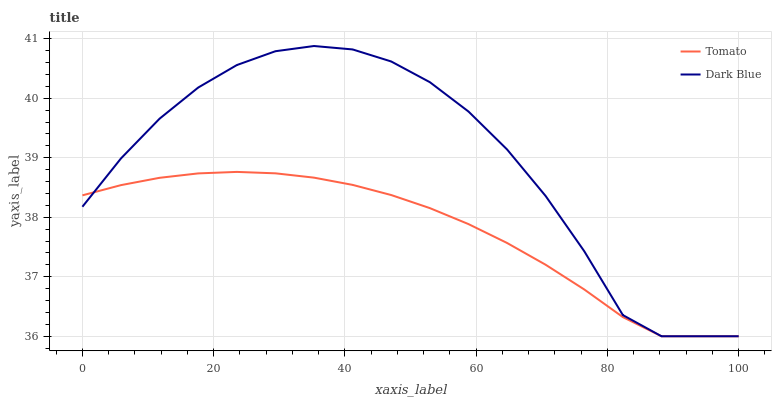Does Dark Blue have the minimum area under the curve?
Answer yes or no. No. Is Dark Blue the smoothest?
Answer yes or no. No. 